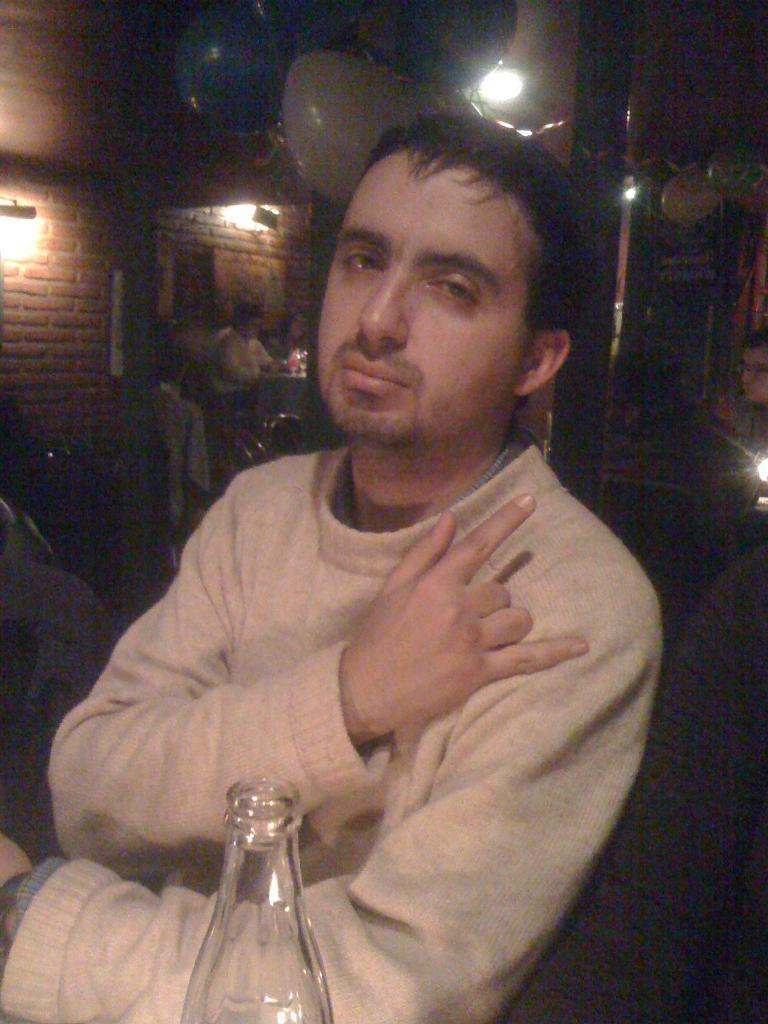Who is the main subject in the image? There is a man in the image. What is the man doing in the image? The man is posing for the camera. What object is in front of the man? There is a bottle in front of the man. What type of ice can be seen melting on the man's head in the image? There is no ice present on the man's head in the image. Can you describe the toad that is sitting next to the man in the image? There is no toad present in the image. 